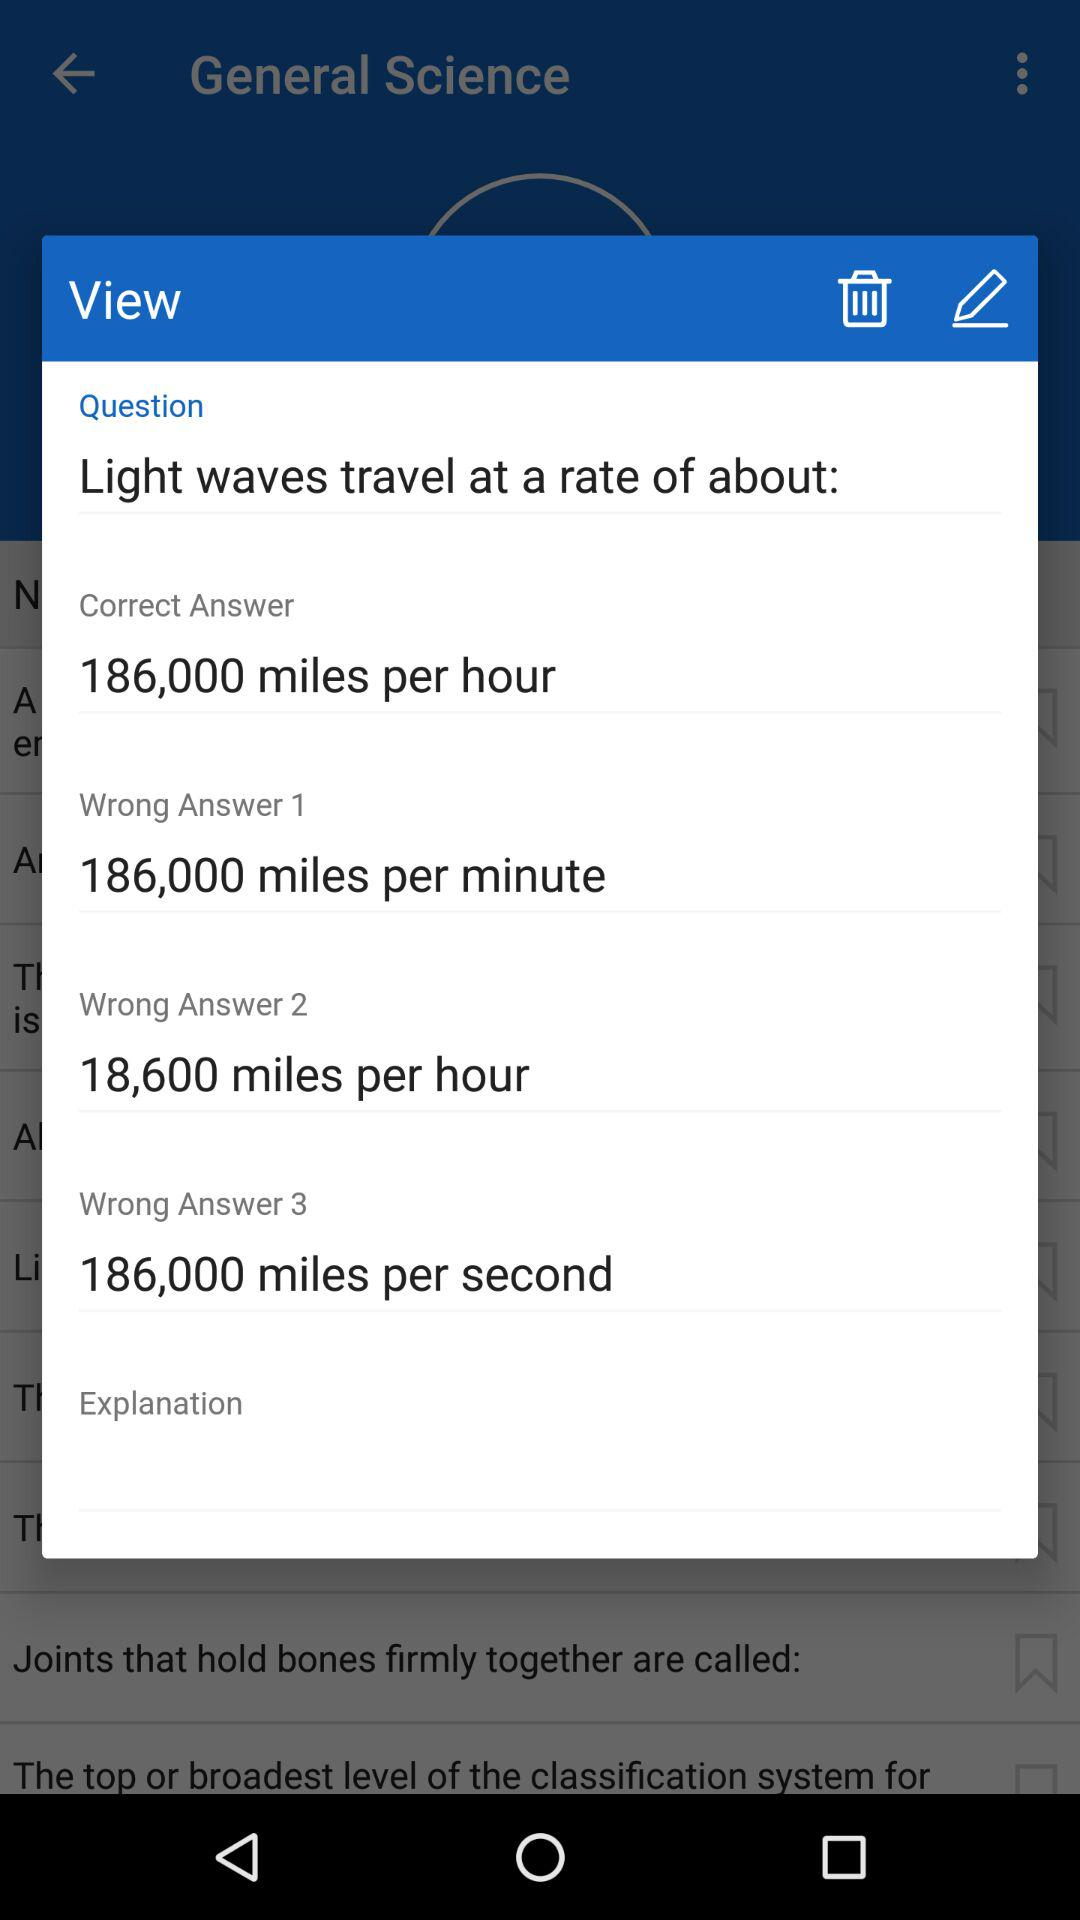How many miles per hour is the correct answer?
Answer the question using a single word or phrase. 186,000 